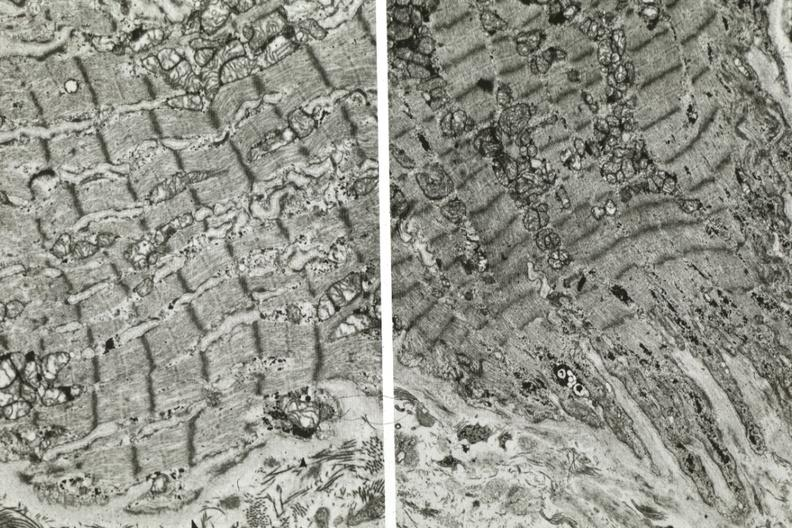does this image show electron micrographs demonstrating fiber does not connect with another fiber other frame shows dilated sarcoplasmic reticulum?
Answer the question using a single word or phrase. Yes 